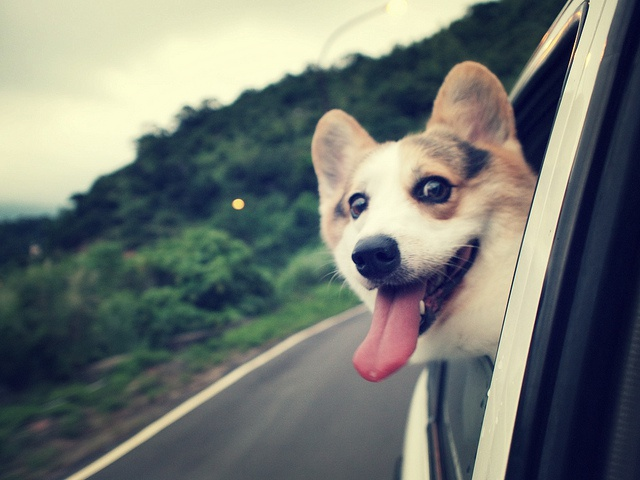Describe the objects in this image and their specific colors. I can see a dog in beige, tan, and darkgray tones in this image. 